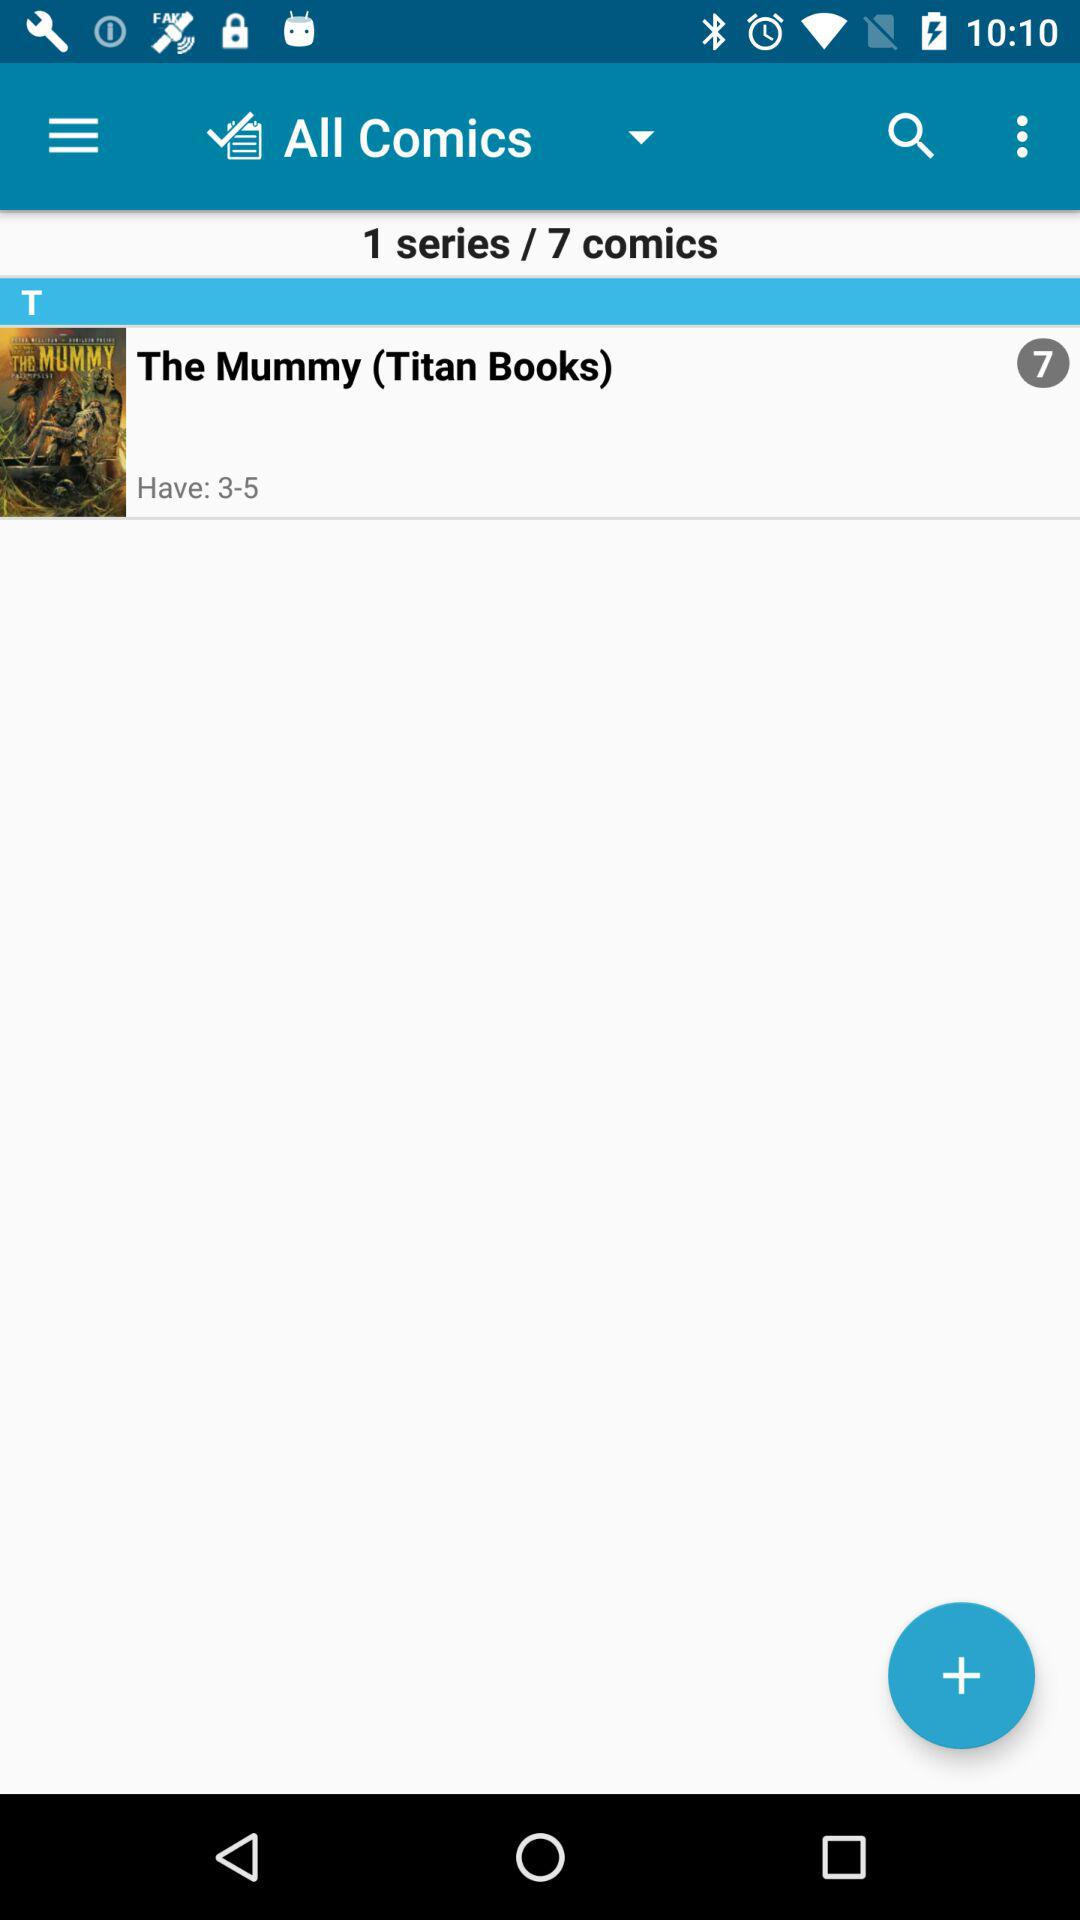How many comics are in the series?
Answer the question using a single word or phrase. 7 